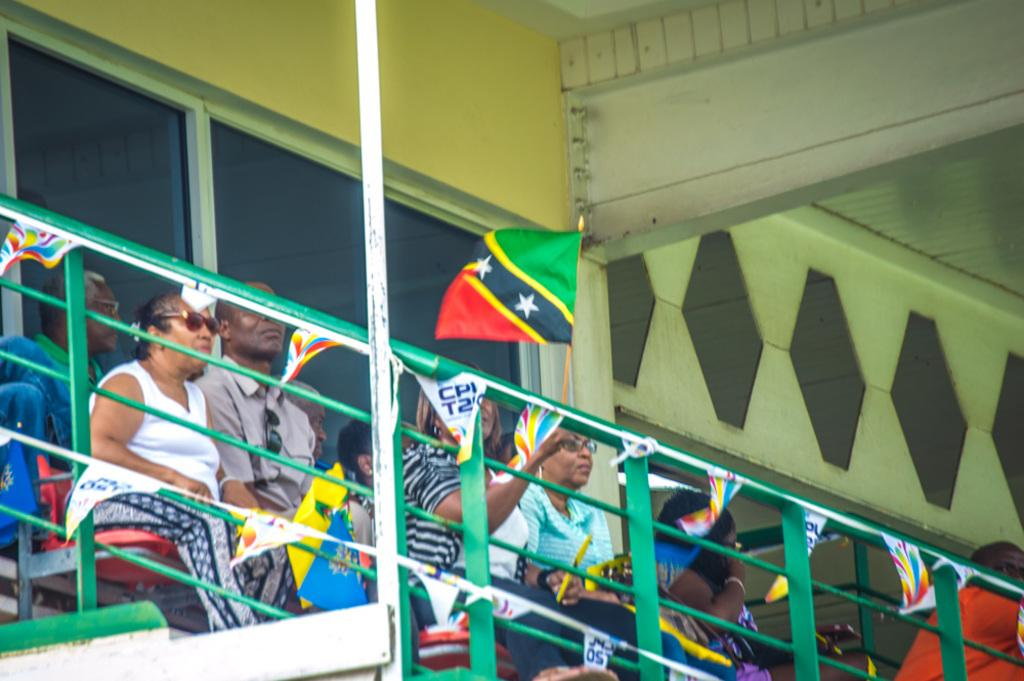Provide a one-sentence caption for the provided image. The small banner hanging from the railing says CPI on it. 